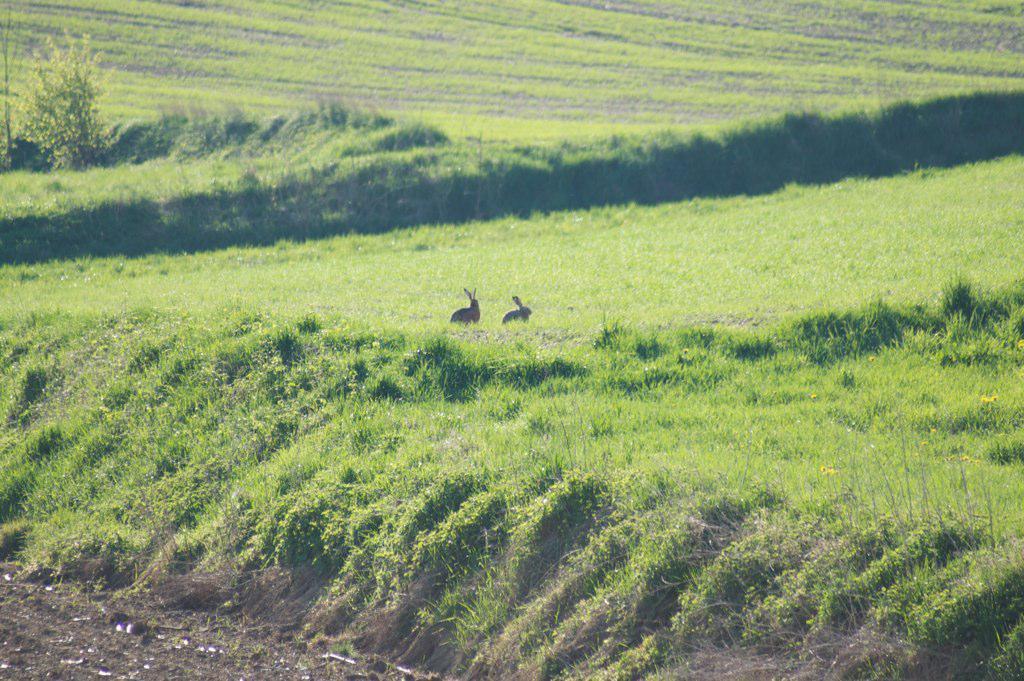Please provide a concise description of this image. In this image there are two rabbits on the ground. On the ground there are grasses, plants. 